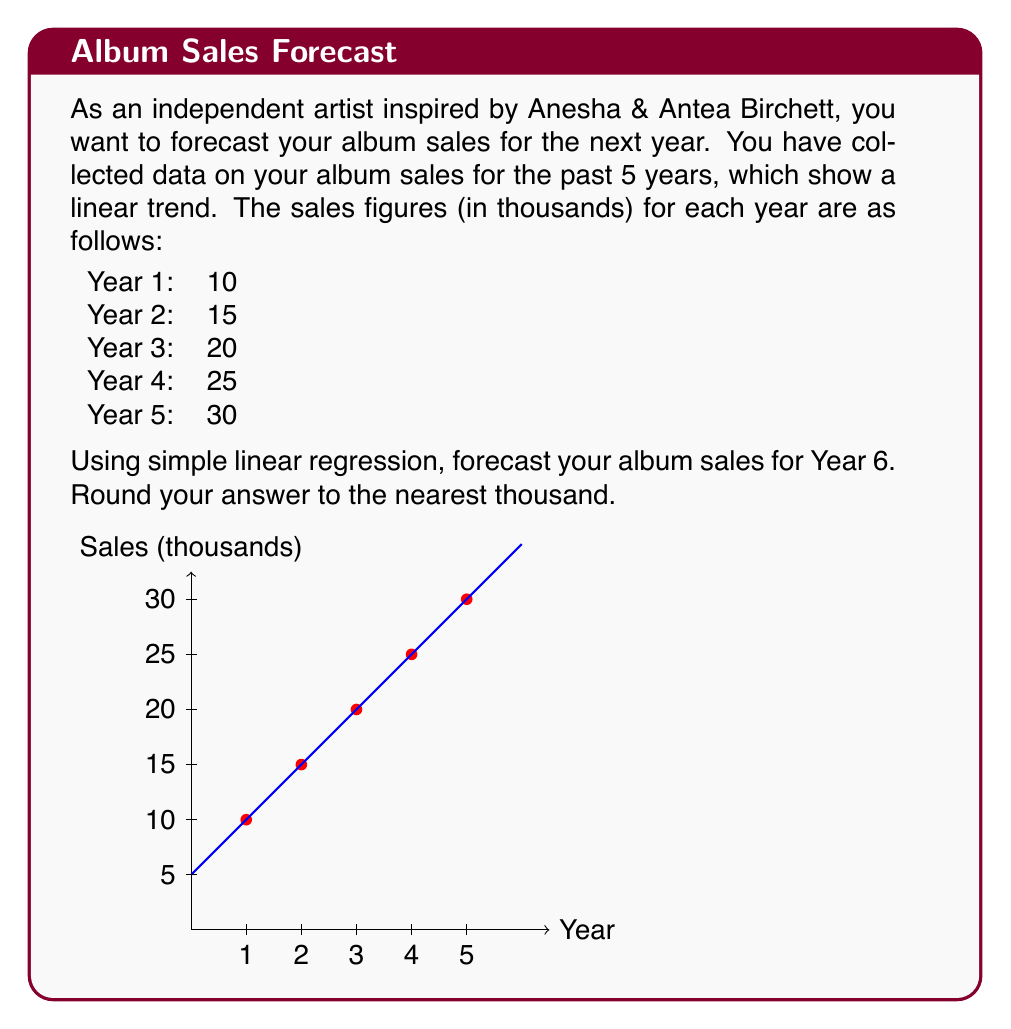Help me with this question. To forecast album sales using simple linear regression, we need to follow these steps:

1. Calculate the slope (m) and y-intercept (b) of the line of best fit.

2. The formula for simple linear regression is:
   $$ y = mx + b $$
   where $y$ is the predicted sales, $x$ is the year, $m$ is the slope, and $b$ is the y-intercept.

3. To find the slope (m), we can use the formula:
   $$ m = \frac{\sum_{i=1}^{n} (x_i - \bar{x})(y_i - \bar{y})}{\sum_{i=1}^{n} (x_i - \bar{x})^2} $$

4. Calculate the means:
   $\bar{x} = (1+2+3+4+5)/5 = 3$
   $\bar{y} = (10+15+20+25+30)/5 = 20$

5. Calculate the numerator and denominator:
   Numerator: $(1-3)(10-20) + (2-3)(15-20) + (3-3)(20-20) + (4-3)(25-20) + (5-3)(30-20) = 50$
   Denominator: $(1-3)^2 + (2-3)^2 + (3-3)^2 + (4-3)^2 + (5-3)^2 = 10$

6. Calculate the slope:
   $m = 50/10 = 5$

7. Use the point-slope form to find b:
   $20 = 5(3) + b$
   $b = 20 - 15 = 5$

8. Our linear regression equation is:
   $$ y = 5x + 5 $$

9. To forecast Year 6 sales, substitute $x = 6$:
   $y = 5(6) + 5 = 35$

Therefore, the forecasted album sales for Year 6 is 35 thousand.
Answer: 35 thousand 